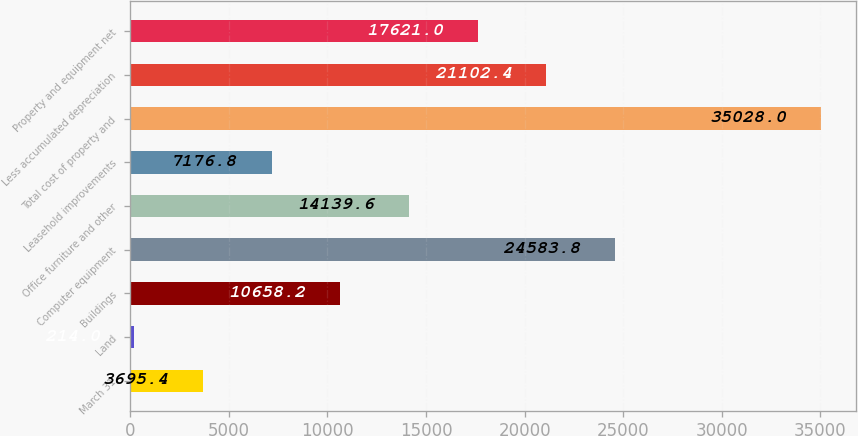<chart> <loc_0><loc_0><loc_500><loc_500><bar_chart><fcel>March 31<fcel>Land<fcel>Buildings<fcel>Computer equipment<fcel>Office furniture and other<fcel>Leasehold improvements<fcel>Total cost of property and<fcel>Less accumulated depreciation<fcel>Property and equipment net<nl><fcel>3695.4<fcel>214<fcel>10658.2<fcel>24583.8<fcel>14139.6<fcel>7176.8<fcel>35028<fcel>21102.4<fcel>17621<nl></chart> 